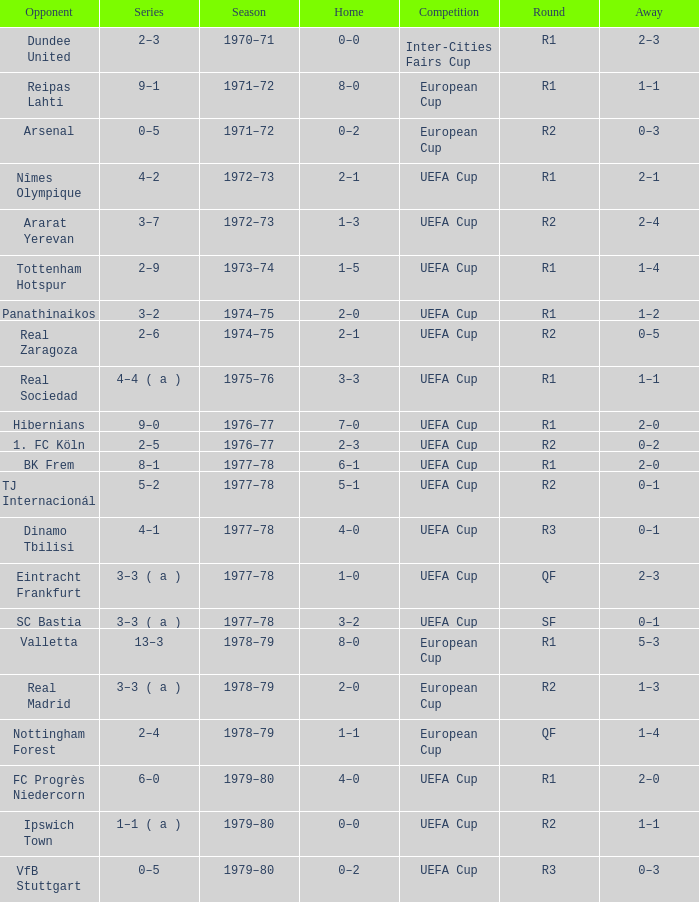Which Home has a Competition of european cup, and a Round of qf? 1–1. 